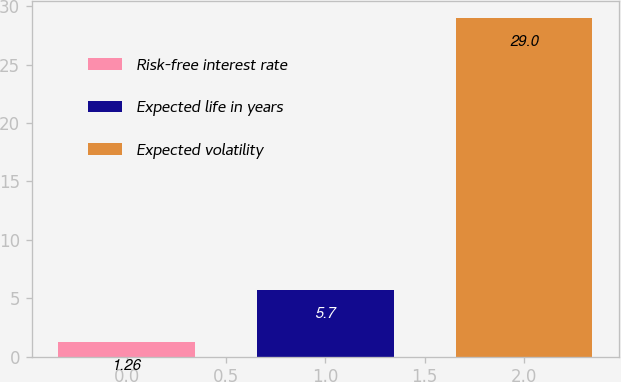Convert chart. <chart><loc_0><loc_0><loc_500><loc_500><bar_chart><fcel>Risk-free interest rate<fcel>Expected life in years<fcel>Expected volatility<nl><fcel>1.26<fcel>5.7<fcel>29<nl></chart> 